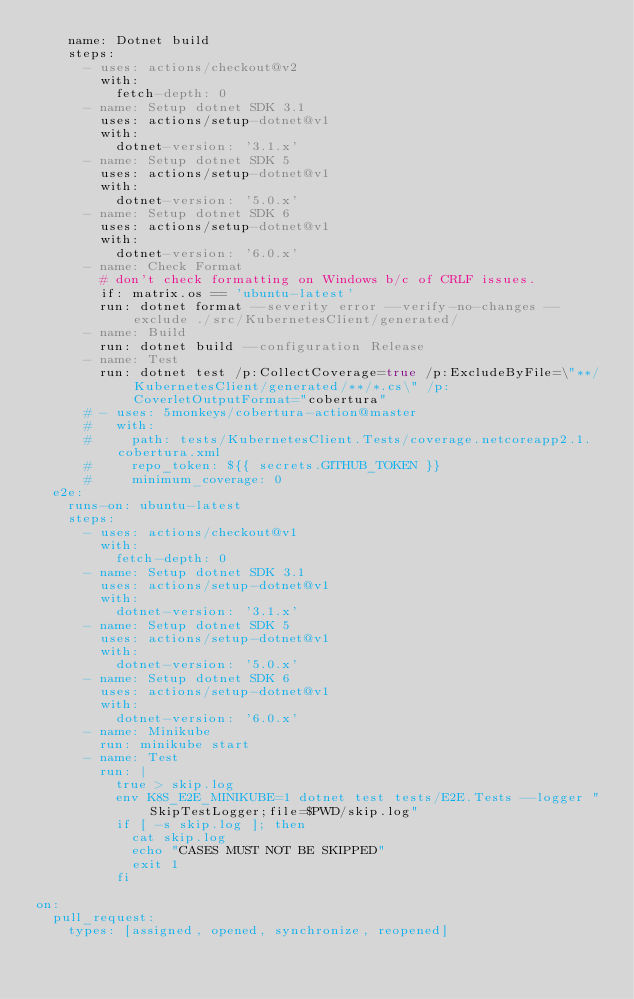Convert code to text. <code><loc_0><loc_0><loc_500><loc_500><_YAML_>    name: Dotnet build
    steps:
      - uses: actions/checkout@v2
        with:
          fetch-depth: 0
      - name: Setup dotnet SDK 3.1
        uses: actions/setup-dotnet@v1
        with:
          dotnet-version: '3.1.x'          
      - name: Setup dotnet SDK 5
        uses: actions/setup-dotnet@v1
        with:
          dotnet-version: '5.0.x'          
      - name: Setup dotnet SDK 6
        uses: actions/setup-dotnet@v1
        with:
          dotnet-version: '6.0.x'          
      - name: Check Format
        # don't check formatting on Windows b/c of CRLF issues.
        if: matrix.os == 'ubuntu-latest'
        run: dotnet format --severity error --verify-no-changes --exclude ./src/KubernetesClient/generated/
      - name: Build
        run: dotnet build --configuration Release
      - name: Test
        run: dotnet test /p:CollectCoverage=true /p:ExcludeByFile=\"**/KubernetesClient/generated/**/*.cs\" /p:CoverletOutputFormat="cobertura"
      # - uses: 5monkeys/cobertura-action@master
      #   with:
      #     path: tests/KubernetesClient.Tests/coverage.netcoreapp2.1.cobertura.xml
      #     repo_token: ${{ secrets.GITHUB_TOKEN }}
      #     minimum_coverage: 0
  e2e:
    runs-on: ubuntu-latest
    steps:
      - uses: actions/checkout@v1
        with:
          fetch-depth: 0
      - name: Setup dotnet SDK 3.1
        uses: actions/setup-dotnet@v1
        with:
          dotnet-version: '3.1.x'          
      - name: Setup dotnet SDK 5
        uses: actions/setup-dotnet@v1
        with:
          dotnet-version: '5.0.x'                
      - name: Setup dotnet SDK 6
        uses: actions/setup-dotnet@v1
        with:
          dotnet-version: '6.0.x'          
      - name: Minikube
        run: minikube start
      - name: Test
        run: |
          true > skip.log
          env K8S_E2E_MINIKUBE=1 dotnet test tests/E2E.Tests --logger "SkipTestLogger;file=$PWD/skip.log"
          if [ -s skip.log ]; then
            cat skip.log
            echo "CASES MUST NOT BE SKIPPED"
            exit 1
          fi      

on:
  pull_request:
    types: [assigned, opened, synchronize, reopened]
</code> 